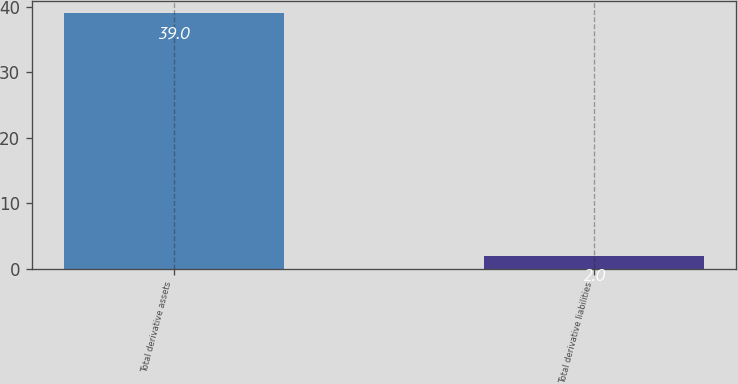<chart> <loc_0><loc_0><loc_500><loc_500><bar_chart><fcel>Total derivative assets<fcel>Total derivative liabilities<nl><fcel>39<fcel>2<nl></chart> 